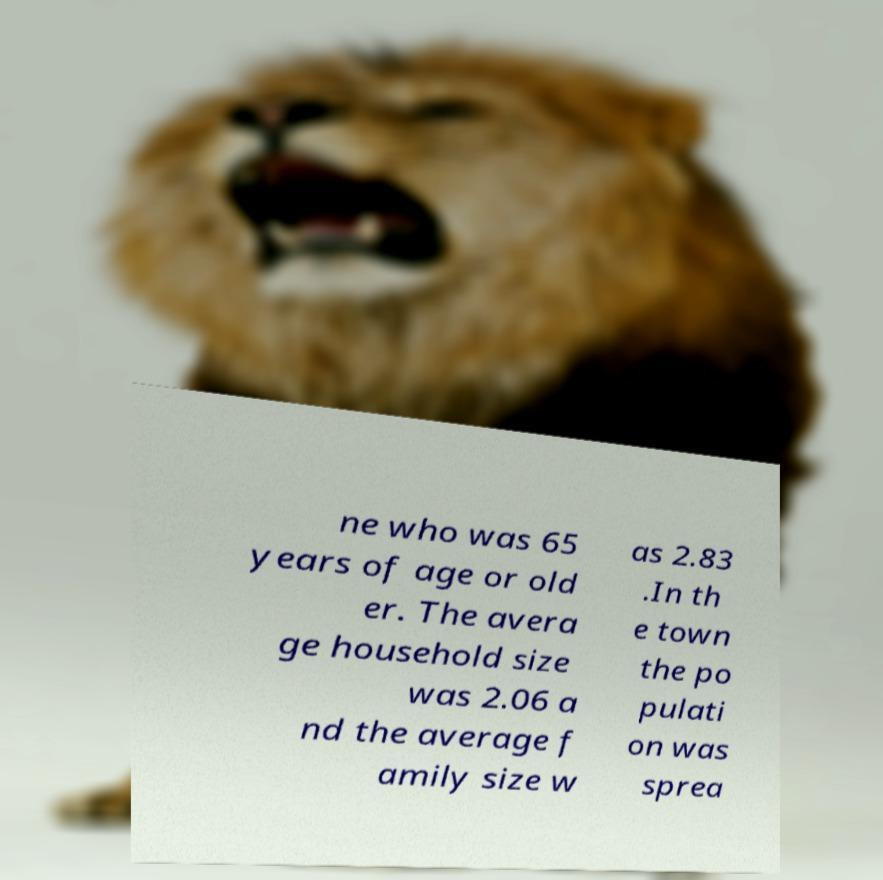Please read and relay the text visible in this image. What does it say? ne who was 65 years of age or old er. The avera ge household size was 2.06 a nd the average f amily size w as 2.83 .In th e town the po pulati on was sprea 